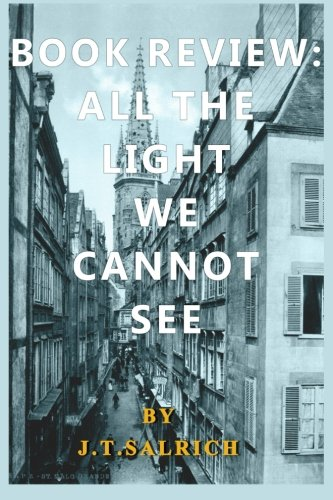How might the cover relate to the story within the book? The historical and slightly somber tone of the cityscape on the cover could suggest themes of history, conflict, or survival, which are central to the story narrated within the pages of 'All the Light We Cannot See.' 